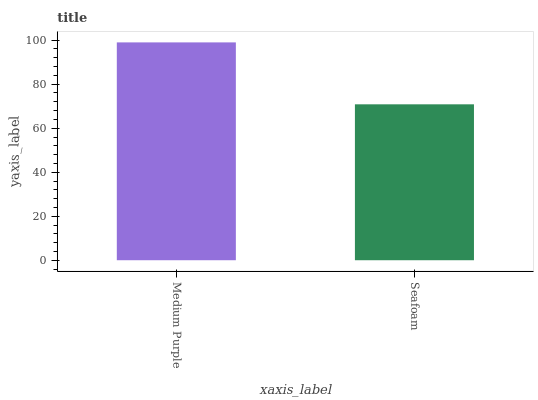Is Seafoam the minimum?
Answer yes or no. Yes. Is Medium Purple the maximum?
Answer yes or no. Yes. Is Seafoam the maximum?
Answer yes or no. No. Is Medium Purple greater than Seafoam?
Answer yes or no. Yes. Is Seafoam less than Medium Purple?
Answer yes or no. Yes. Is Seafoam greater than Medium Purple?
Answer yes or no. No. Is Medium Purple less than Seafoam?
Answer yes or no. No. Is Medium Purple the high median?
Answer yes or no. Yes. Is Seafoam the low median?
Answer yes or no. Yes. Is Seafoam the high median?
Answer yes or no. No. Is Medium Purple the low median?
Answer yes or no. No. 